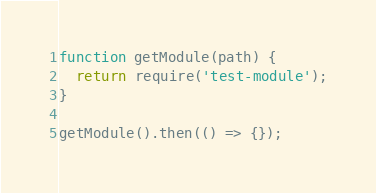<code> <loc_0><loc_0><loc_500><loc_500><_JavaScript_>function getModule(path) {
  return require('test-module');
}

getModule().then(() => {});
</code> 